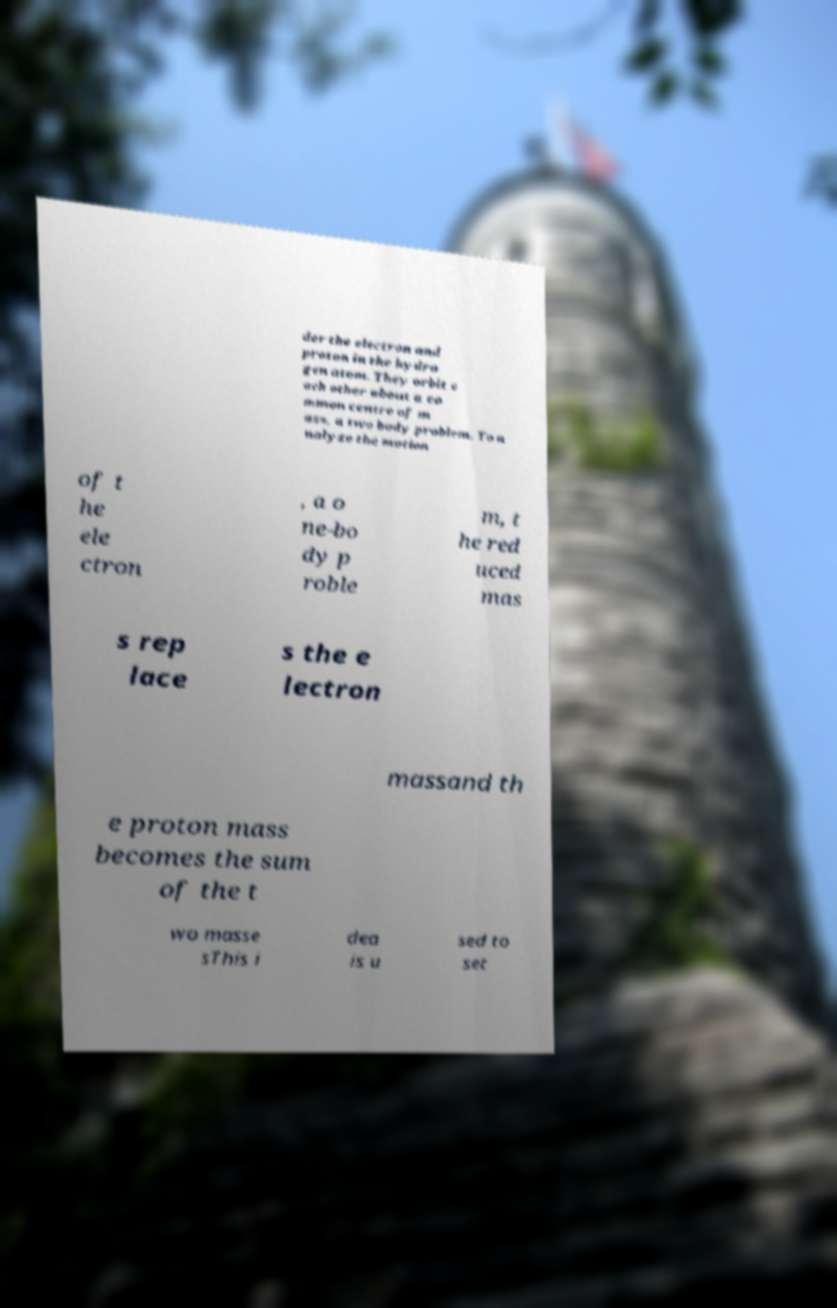Can you accurately transcribe the text from the provided image for me? der the electron and proton in the hydro gen atom. They orbit e ach other about a co mmon centre of m ass, a two body problem. To a nalyze the motion of t he ele ctron , a o ne-bo dy p roble m, t he red uced mas s rep lace s the e lectron massand th e proton mass becomes the sum of the t wo masse sThis i dea is u sed to set 